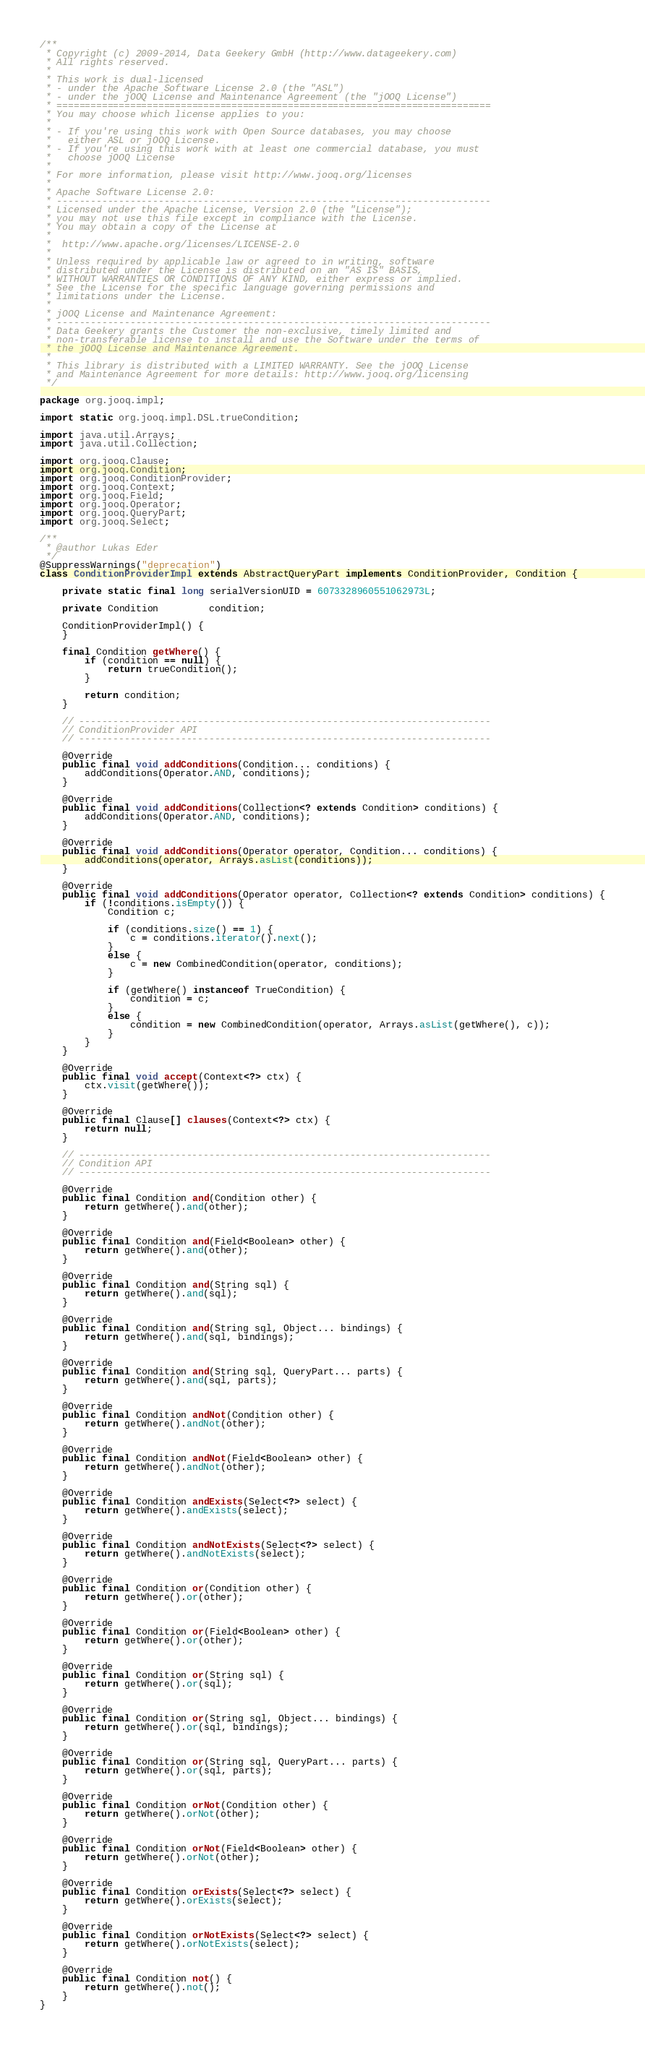Convert code to text. <code><loc_0><loc_0><loc_500><loc_500><_Java_>/**
 * Copyright (c) 2009-2014, Data Geekery GmbH (http://www.datageekery.com)
 * All rights reserved.
 *
 * This work is dual-licensed
 * - under the Apache Software License 2.0 (the "ASL")
 * - under the jOOQ License and Maintenance Agreement (the "jOOQ License")
 * =============================================================================
 * You may choose which license applies to you:
 *
 * - If you're using this work with Open Source databases, you may choose
 *   either ASL or jOOQ License.
 * - If you're using this work with at least one commercial database, you must
 *   choose jOOQ License
 *
 * For more information, please visit http://www.jooq.org/licenses
 *
 * Apache Software License 2.0:
 * -----------------------------------------------------------------------------
 * Licensed under the Apache License, Version 2.0 (the "License");
 * you may not use this file except in compliance with the License.
 * You may obtain a copy of the License at
 *
 *  http://www.apache.org/licenses/LICENSE-2.0
 *
 * Unless required by applicable law or agreed to in writing, software
 * distributed under the License is distributed on an "AS IS" BASIS,
 * WITHOUT WARRANTIES OR CONDITIONS OF ANY KIND, either express or implied.
 * See the License for the specific language governing permissions and
 * limitations under the License.
 *
 * jOOQ License and Maintenance Agreement:
 * -----------------------------------------------------------------------------
 * Data Geekery grants the Customer the non-exclusive, timely limited and
 * non-transferable license to install and use the Software under the terms of
 * the jOOQ License and Maintenance Agreement.
 *
 * This library is distributed with a LIMITED WARRANTY. See the jOOQ License
 * and Maintenance Agreement for more details: http://www.jooq.org/licensing
 */

package org.jooq.impl;

import static org.jooq.impl.DSL.trueCondition;

import java.util.Arrays;
import java.util.Collection;

import org.jooq.Clause;
import org.jooq.Condition;
import org.jooq.ConditionProvider;
import org.jooq.Context;
import org.jooq.Field;
import org.jooq.Operator;
import org.jooq.QueryPart;
import org.jooq.Select;

/**
 * @author Lukas Eder
 */
@SuppressWarnings("deprecation")
class ConditionProviderImpl extends AbstractQueryPart implements ConditionProvider, Condition {

    private static final long serialVersionUID = 6073328960551062973L;

    private Condition         condition;

    ConditionProviderImpl() {
    }

    final Condition getWhere() {
        if (condition == null) {
            return trueCondition();
        }

        return condition;
    }

    // -------------------------------------------------------------------------
    // ConditionProvider API
    // -------------------------------------------------------------------------

    @Override
    public final void addConditions(Condition... conditions) {
        addConditions(Operator.AND, conditions);
    }

    @Override
    public final void addConditions(Collection<? extends Condition> conditions) {
        addConditions(Operator.AND, conditions);
    }

    @Override
    public final void addConditions(Operator operator, Condition... conditions) {
        addConditions(operator, Arrays.asList(conditions));
    }

    @Override
    public final void addConditions(Operator operator, Collection<? extends Condition> conditions) {
        if (!conditions.isEmpty()) {
            Condition c;

            if (conditions.size() == 1) {
                c = conditions.iterator().next();
            }
            else {
                c = new CombinedCondition(operator, conditions);
            }

            if (getWhere() instanceof TrueCondition) {
                condition = c;
            }
            else {
                condition = new CombinedCondition(operator, Arrays.asList(getWhere(), c));
            }
        }
    }

    @Override
    public final void accept(Context<?> ctx) {
        ctx.visit(getWhere());
    }

    @Override
    public final Clause[] clauses(Context<?> ctx) {
        return null;
    }

    // -------------------------------------------------------------------------
    // Condition API
    // -------------------------------------------------------------------------

    @Override
    public final Condition and(Condition other) {
        return getWhere().and(other);
    }

    @Override
    public final Condition and(Field<Boolean> other) {
        return getWhere().and(other);
    }

    @Override
    public final Condition and(String sql) {
        return getWhere().and(sql);
    }

    @Override
    public final Condition and(String sql, Object... bindings) {
        return getWhere().and(sql, bindings);
    }

    @Override
    public final Condition and(String sql, QueryPart... parts) {
        return getWhere().and(sql, parts);
    }

    @Override
    public final Condition andNot(Condition other) {
        return getWhere().andNot(other);
    }

    @Override
    public final Condition andNot(Field<Boolean> other) {
        return getWhere().andNot(other);
    }

    @Override
    public final Condition andExists(Select<?> select) {
        return getWhere().andExists(select);
    }

    @Override
    public final Condition andNotExists(Select<?> select) {
        return getWhere().andNotExists(select);
    }

    @Override
    public final Condition or(Condition other) {
        return getWhere().or(other);
    }

    @Override
    public final Condition or(Field<Boolean> other) {
        return getWhere().or(other);
    }

    @Override
    public final Condition or(String sql) {
        return getWhere().or(sql);
    }

    @Override
    public final Condition or(String sql, Object... bindings) {
        return getWhere().or(sql, bindings);
    }

    @Override
    public final Condition or(String sql, QueryPart... parts) {
        return getWhere().or(sql, parts);
    }

    @Override
    public final Condition orNot(Condition other) {
        return getWhere().orNot(other);
    }

    @Override
    public final Condition orNot(Field<Boolean> other) {
        return getWhere().orNot(other);
    }

    @Override
    public final Condition orExists(Select<?> select) {
        return getWhere().orExists(select);
    }

    @Override
    public final Condition orNotExists(Select<?> select) {
        return getWhere().orNotExists(select);
    }

    @Override
    public final Condition not() {
        return getWhere().not();
    }
}
</code> 